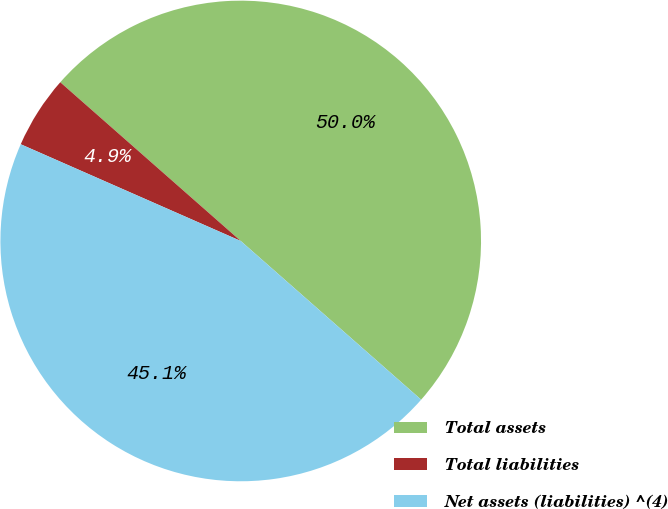Convert chart. <chart><loc_0><loc_0><loc_500><loc_500><pie_chart><fcel>Total assets<fcel>Total liabilities<fcel>Net assets (liabilities) ^(4)<nl><fcel>50.0%<fcel>4.89%<fcel>45.11%<nl></chart> 